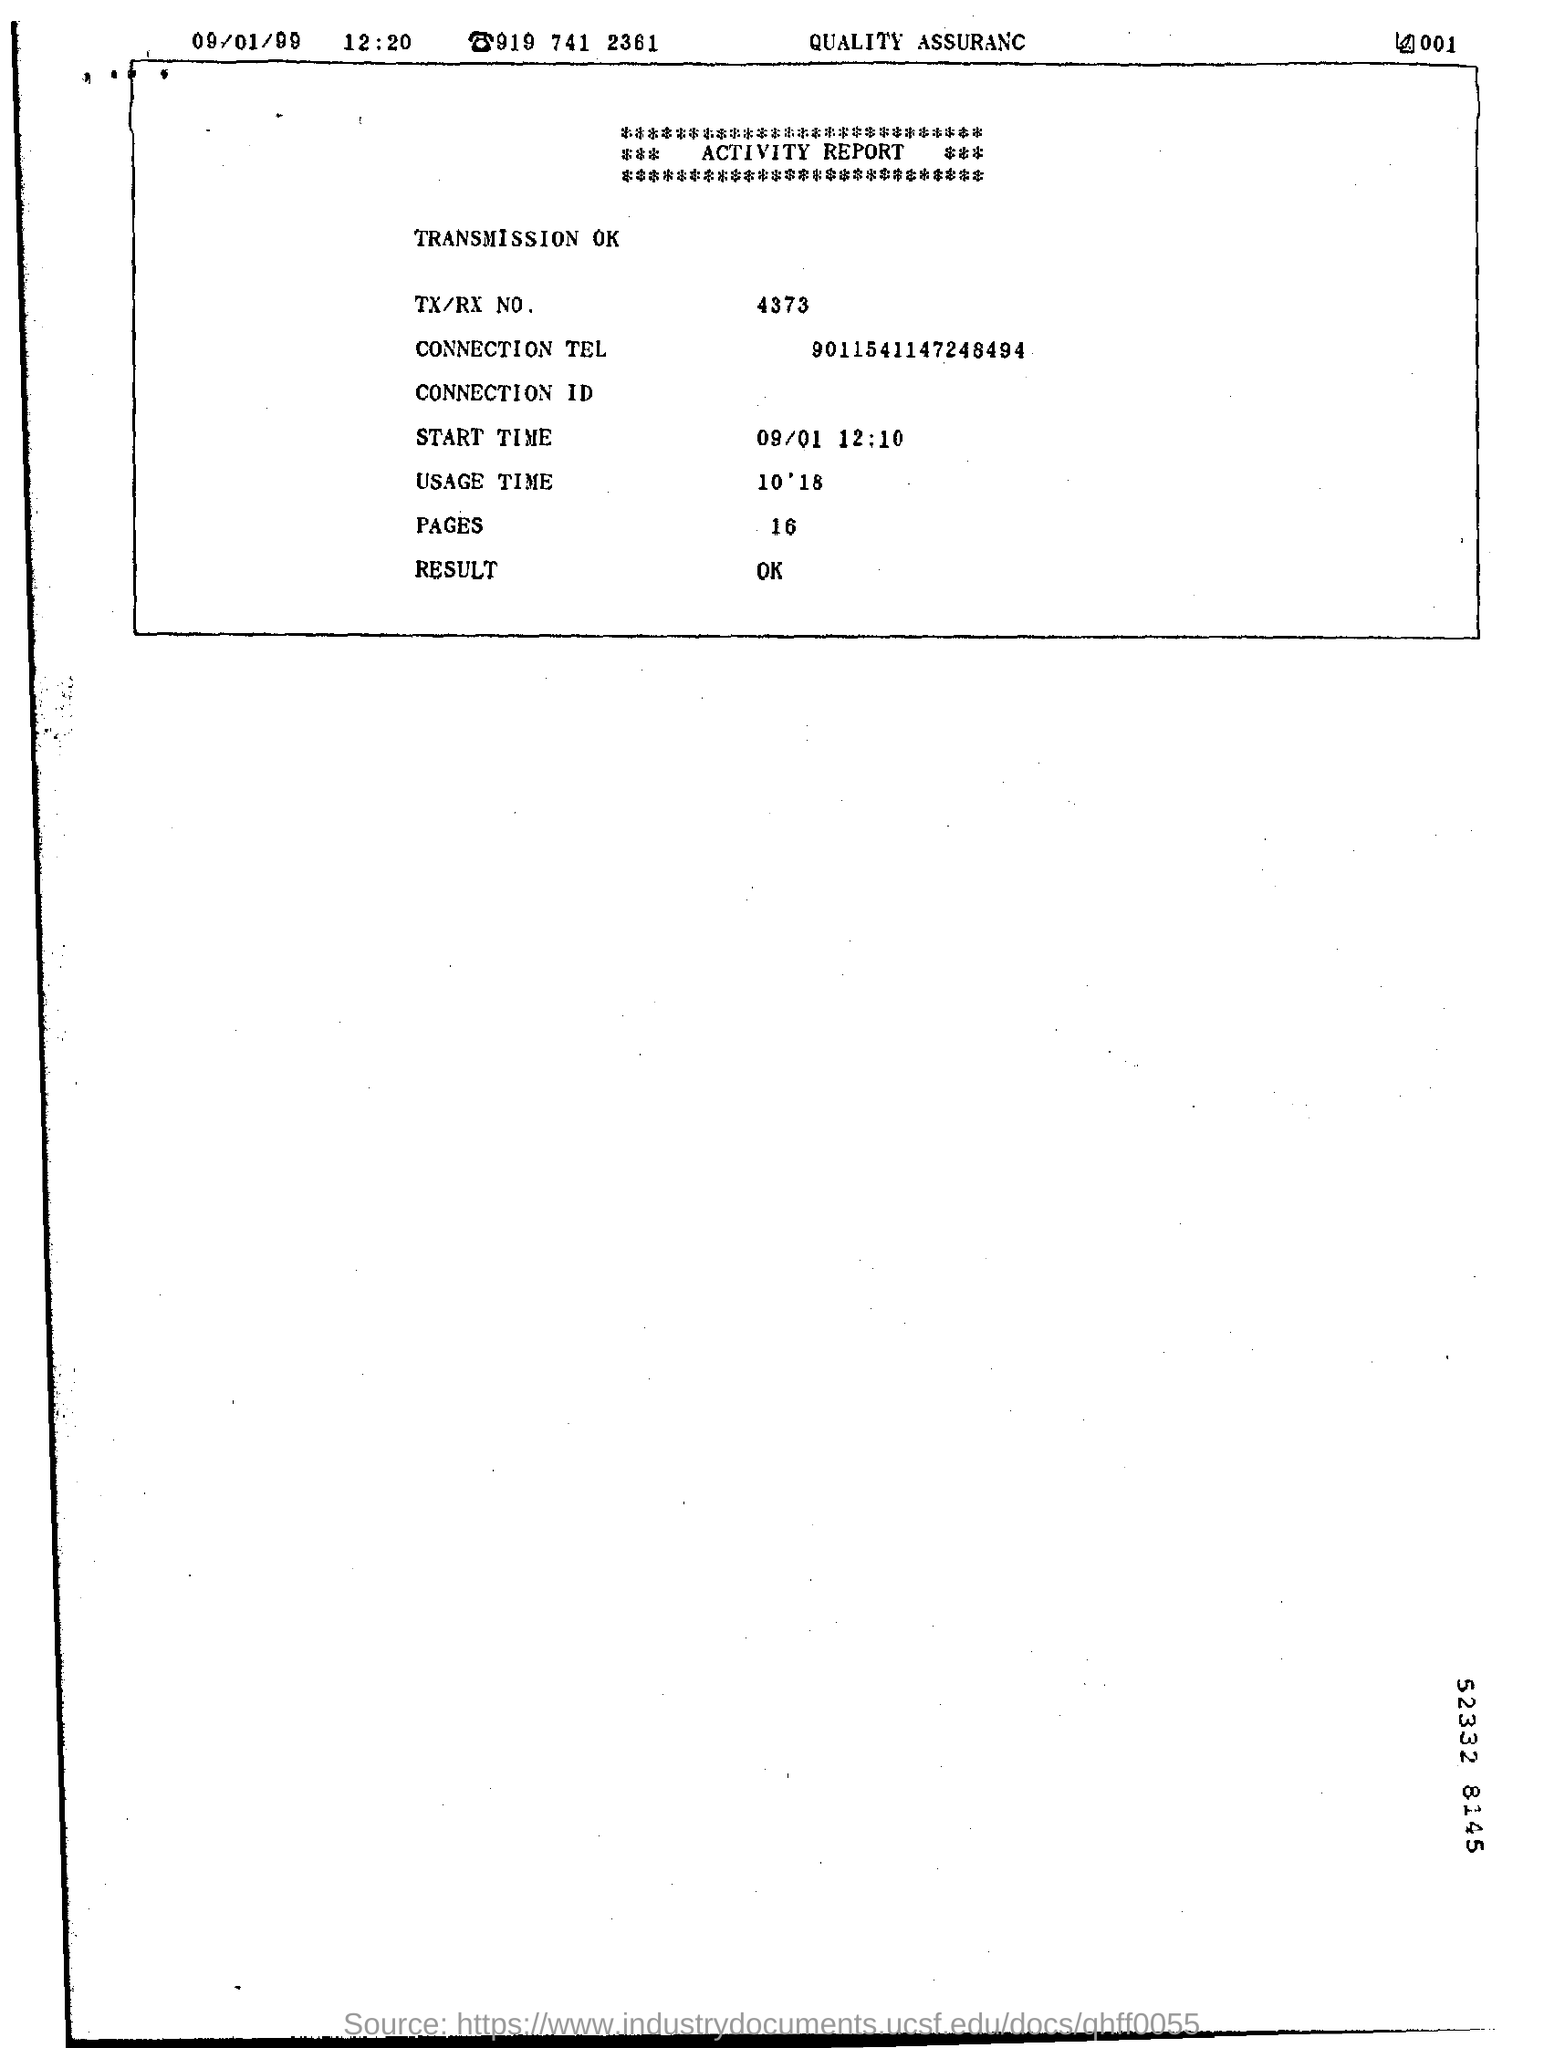List a handful of essential elements in this visual. The number "What is the Connection Tel? 9011541147248494..." is a telephone number. The start time is 09/01 at 12:10. The TX/RX number is 4373. The usage time is 10 minutes and 18 seconds. 